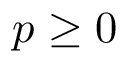<formula> <loc_0><loc_0><loc_500><loc_500>p \geq 0</formula> 